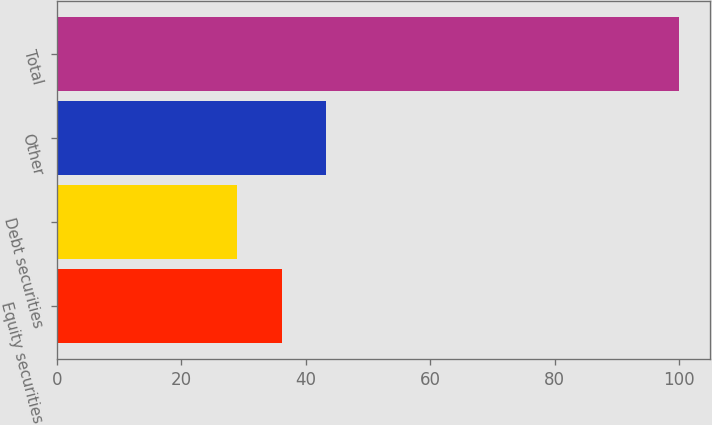Convert chart. <chart><loc_0><loc_0><loc_500><loc_500><bar_chart><fcel>Equity securities<fcel>Debt securities<fcel>Other<fcel>Total<nl><fcel>36.1<fcel>29<fcel>43.2<fcel>100<nl></chart> 